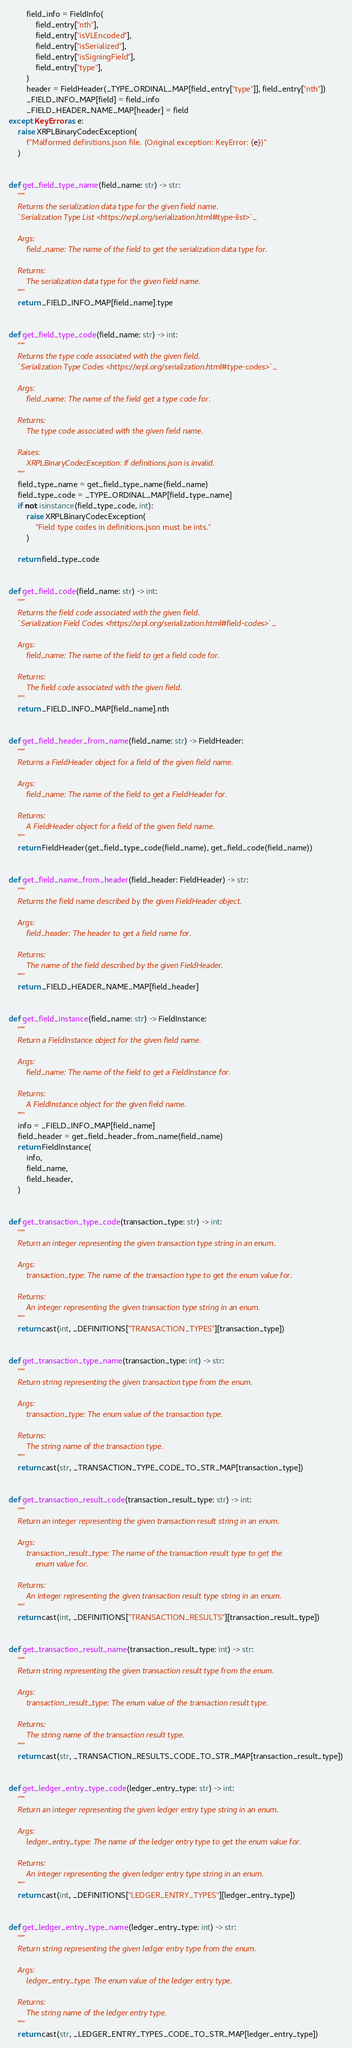<code> <loc_0><loc_0><loc_500><loc_500><_Python_>        field_info = FieldInfo(
            field_entry["nth"],
            field_entry["isVLEncoded"],
            field_entry["isSerialized"],
            field_entry["isSigningField"],
            field_entry["type"],
        )
        header = FieldHeader(_TYPE_ORDINAL_MAP[field_entry["type"]], field_entry["nth"])
        _FIELD_INFO_MAP[field] = field_info
        _FIELD_HEADER_NAME_MAP[header] = field
except KeyError as e:
    raise XRPLBinaryCodecException(
        f"Malformed definitions.json file. (Original exception: KeyError: {e})"
    )


def get_field_type_name(field_name: str) -> str:
    """
    Returns the serialization data type for the given field name.
    `Serialization Type List <https://xrpl.org/serialization.html#type-list>`_

    Args:
        field_name: The name of the field to get the serialization data type for.

    Returns:
        The serialization data type for the given field name.
    """
    return _FIELD_INFO_MAP[field_name].type


def get_field_type_code(field_name: str) -> int:
    """
    Returns the type code associated with the given field.
    `Serialization Type Codes <https://xrpl.org/serialization.html#type-codes>`_

    Args:
        field_name: The name of the field get a type code for.

    Returns:
        The type code associated with the given field name.

    Raises:
        XRPLBinaryCodecException: If definitions.json is invalid.
    """
    field_type_name = get_field_type_name(field_name)
    field_type_code = _TYPE_ORDINAL_MAP[field_type_name]
    if not isinstance(field_type_code, int):
        raise XRPLBinaryCodecException(
            "Field type codes in definitions.json must be ints."
        )

    return field_type_code


def get_field_code(field_name: str) -> int:
    """
    Returns the field code associated with the given field.
    `Serialization Field Codes <https://xrpl.org/serialization.html#field-codes>`_

    Args:
        field_name: The name of the field to get a field code for.

    Returns:
        The field code associated with the given field.
    """
    return _FIELD_INFO_MAP[field_name].nth


def get_field_header_from_name(field_name: str) -> FieldHeader:
    """
    Returns a FieldHeader object for a field of the given field name.

    Args:
        field_name: The name of the field to get a FieldHeader for.

    Returns:
        A FieldHeader object for a field of the given field name.
    """
    return FieldHeader(get_field_type_code(field_name), get_field_code(field_name))


def get_field_name_from_header(field_header: FieldHeader) -> str:
    """
    Returns the field name described by the given FieldHeader object.

    Args:
        field_header: The header to get a field name for.

    Returns:
        The name of the field described by the given FieldHeader.
    """
    return _FIELD_HEADER_NAME_MAP[field_header]


def get_field_instance(field_name: str) -> FieldInstance:
    """
    Return a FieldInstance object for the given field name.

    Args:
        field_name: The name of the field to get a FieldInstance for.

    Returns:
        A FieldInstance object for the given field name.
    """
    info = _FIELD_INFO_MAP[field_name]
    field_header = get_field_header_from_name(field_name)
    return FieldInstance(
        info,
        field_name,
        field_header,
    )


def get_transaction_type_code(transaction_type: str) -> int:
    """
    Return an integer representing the given transaction type string in an enum.

    Args:
        transaction_type: The name of the transaction type to get the enum value for.

    Returns:
        An integer representing the given transaction type string in an enum.
    """
    return cast(int, _DEFINITIONS["TRANSACTION_TYPES"][transaction_type])


def get_transaction_type_name(transaction_type: int) -> str:
    """
    Return string representing the given transaction type from the enum.

    Args:
        transaction_type: The enum value of the transaction type.

    Returns:
        The string name of the transaction type.
    """
    return cast(str, _TRANSACTION_TYPE_CODE_TO_STR_MAP[transaction_type])


def get_transaction_result_code(transaction_result_type: str) -> int:
    """
    Return an integer representing the given transaction result string in an enum.

    Args:
        transaction_result_type: The name of the transaction result type to get the
            enum value for.

    Returns:
        An integer representing the given transaction result type string in an enum.
    """
    return cast(int, _DEFINITIONS["TRANSACTION_RESULTS"][transaction_result_type])


def get_transaction_result_name(transaction_result_type: int) -> str:
    """
    Return string representing the given transaction result type from the enum.

    Args:
        transaction_result_type: The enum value of the transaction result type.

    Returns:
        The string name of the transaction result type.
    """
    return cast(str, _TRANSACTION_RESULTS_CODE_TO_STR_MAP[transaction_result_type])


def get_ledger_entry_type_code(ledger_entry_type: str) -> int:
    """
    Return an integer representing the given ledger entry type string in an enum.

    Args:
        ledger_entry_type: The name of the ledger entry type to get the enum value for.

    Returns:
        An integer representing the given ledger entry type string in an enum.
    """
    return cast(int, _DEFINITIONS["LEDGER_ENTRY_TYPES"][ledger_entry_type])


def get_ledger_entry_type_name(ledger_entry_type: int) -> str:
    """
    Return string representing the given ledger entry type from the enum.

    Args:
        ledger_entry_type: The enum value of the ledger entry type.

    Returns:
        The string name of the ledger entry type.
    """
    return cast(str, _LEDGER_ENTRY_TYPES_CODE_TO_STR_MAP[ledger_entry_type])
</code> 